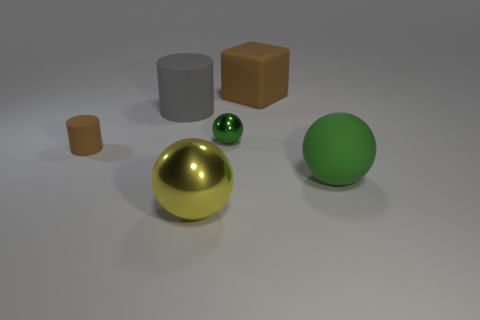What size is the ball that is the same color as the tiny metal thing?
Ensure brevity in your answer.  Large. There is a thing right of the large brown rubber thing; is its color the same as the small sphere?
Ensure brevity in your answer.  Yes. There is a yellow metallic object that is the same shape as the big green thing; what size is it?
Provide a succinct answer. Large. What is the color of the tiny thing right of the sphere in front of the green ball to the right of the tiny green thing?
Your answer should be very brief. Green. Is the yellow sphere made of the same material as the small brown cylinder?
Make the answer very short. No. Are there any shiny spheres in front of the green sphere right of the metal ball that is on the right side of the large yellow object?
Give a very brief answer. Yes. Is the large matte block the same color as the tiny rubber cylinder?
Offer a very short reply. Yes. Is the number of large gray rubber cylinders less than the number of tiny gray rubber blocks?
Your answer should be very brief. No. Does the green object behind the large green rubber object have the same material as the sphere right of the brown cube?
Your answer should be very brief. No. Are there fewer cylinders in front of the small brown matte object than brown metal spheres?
Give a very brief answer. No. 